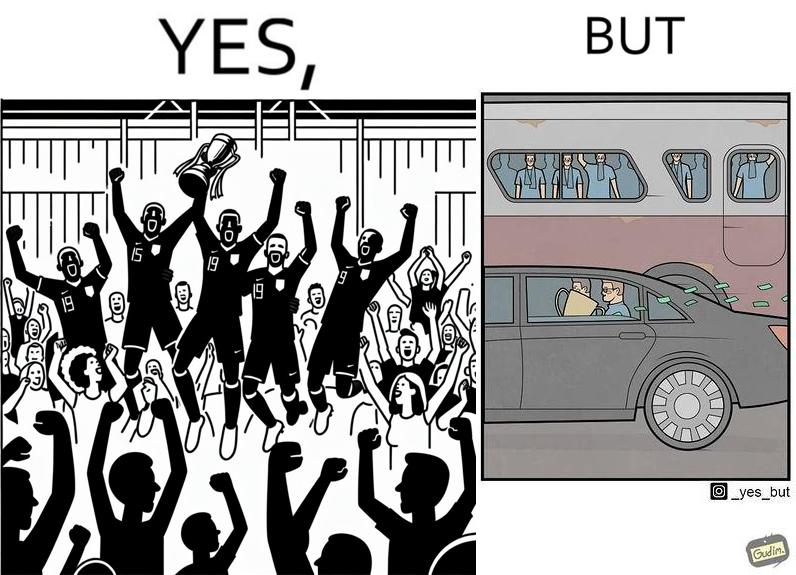Provide a description of this image. The image is ironical, as a team and its are all celebrating on the ground after winning the match, but after the match, the fans are standing in the bus uncomfortably, while the players are travelling inside a carring the cup as well as the prize money, which the fans did not get a dime of. 